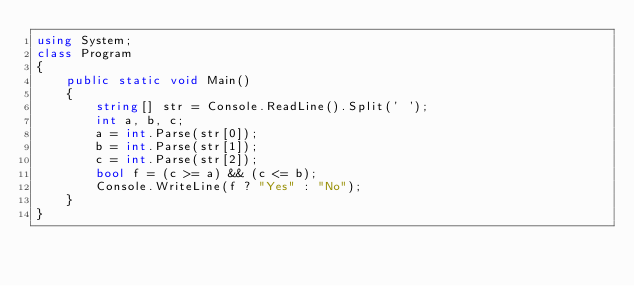Convert code to text. <code><loc_0><loc_0><loc_500><loc_500><_C#_>using System;
class Program
{
    public static void Main()
    {
        string[] str = Console.ReadLine().Split(' ');
        int a, b, c;
        a = int.Parse(str[0]);
        b = int.Parse(str[1]);
        c = int.Parse(str[2]);
        bool f = (c >= a) && (c <= b);
        Console.WriteLine(f ? "Yes" : "No");
    }
}</code> 